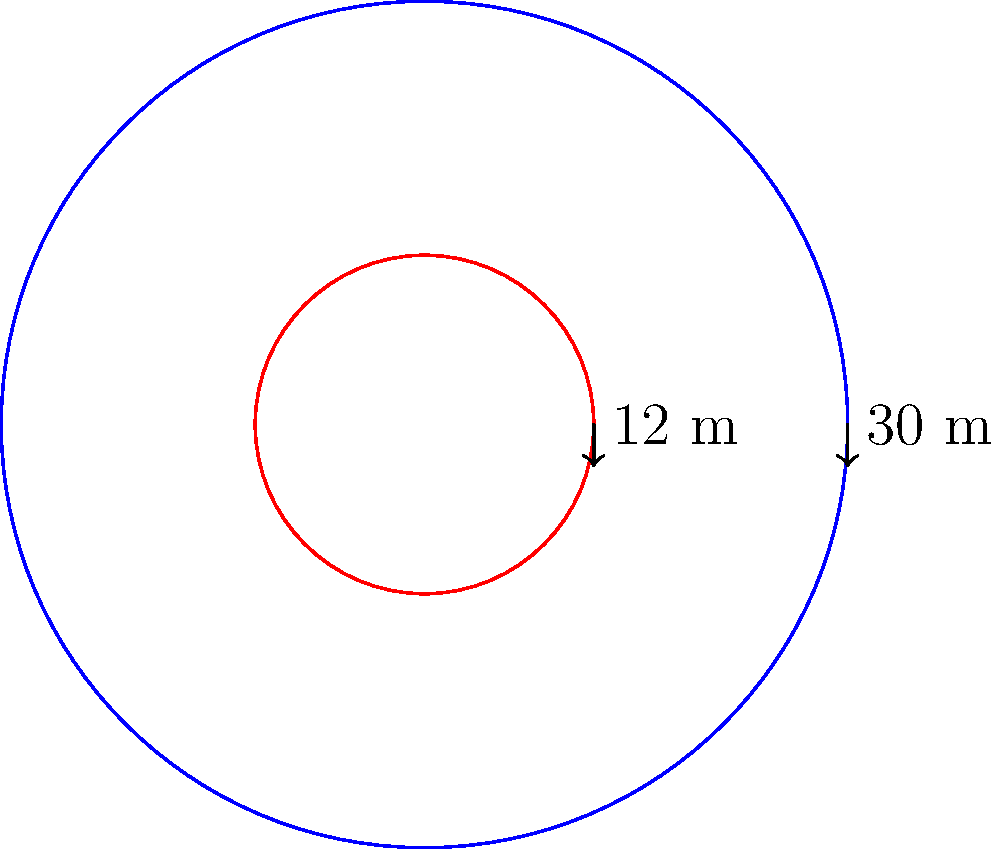As part of a city revitalization project, you're advising on the design of a circular public plaza with a fountain at its center. The plaza has a diameter of 30 meters, and the circular fountain has a diameter of 12 meters. What is the area of the plaza available for public use, excluding the fountain area? To solve this problem, we need to follow these steps:

1) First, let's calculate the areas of both the entire plaza and the fountain:

   Area of a circle = $\pi r^2$, where $r$ is the radius

2) For the entire plaza:
   Diameter = 30 m, so radius = 15 m
   Area of plaza = $\pi (15)^2 = 225\pi$ sq meters

3) For the fountain:
   Diameter = 12 m, so radius = 6 m
   Area of fountain = $\pi (6)^2 = 36\pi$ sq meters

4) The area available for public use is the difference between these two areas:

   Public area = Area of plaza - Area of fountain
                = $225\pi - 36\pi$
                = $189\pi$ sq meters

5) If we need to give a numeric value, we can calculate:
   $189\pi \approx 593.76$ sq meters (rounded to two decimal places)
Answer: $189\pi$ sq meters (or approximately 593.76 sq meters) 